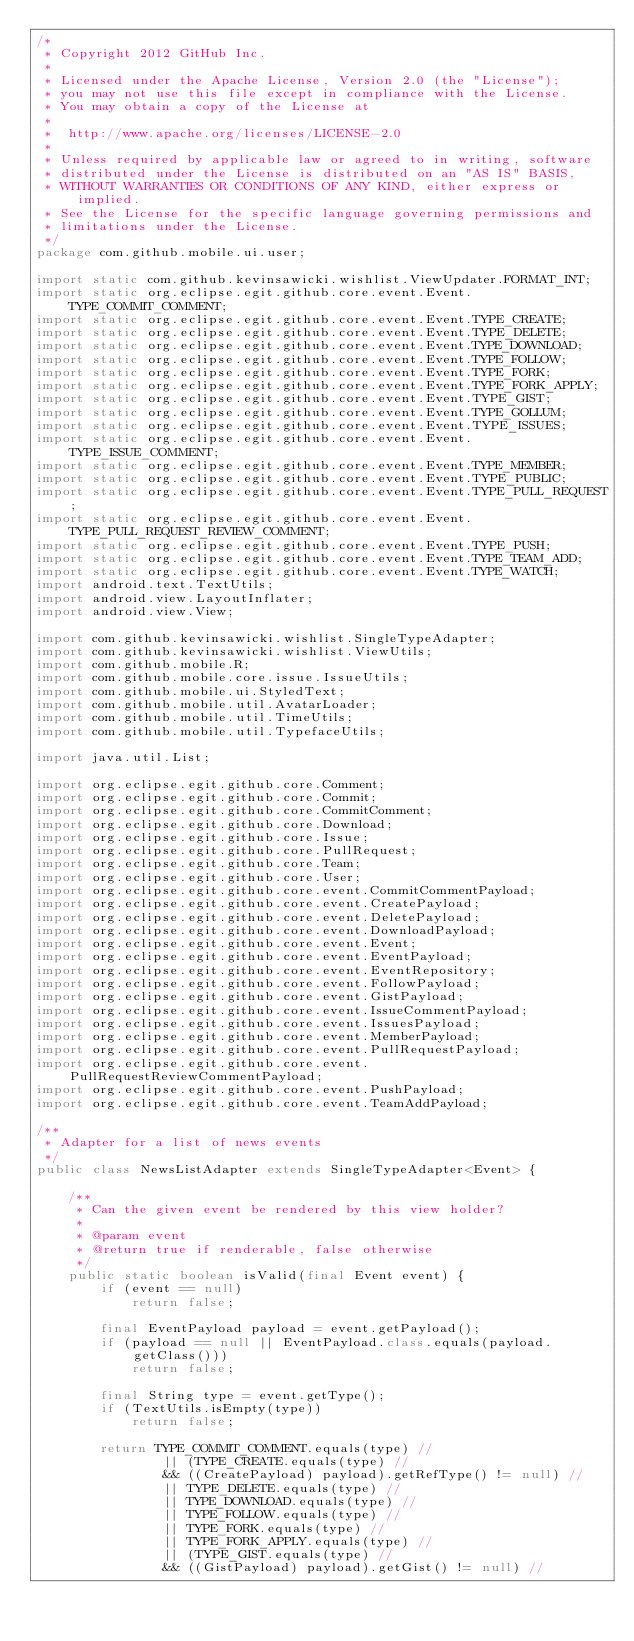Convert code to text. <code><loc_0><loc_0><loc_500><loc_500><_Java_>/*
 * Copyright 2012 GitHub Inc.
 *
 * Licensed under the Apache License, Version 2.0 (the "License");
 * you may not use this file except in compliance with the License.
 * You may obtain a copy of the License at
 *
 *  http://www.apache.org/licenses/LICENSE-2.0
 *
 * Unless required by applicable law or agreed to in writing, software
 * distributed under the License is distributed on an "AS IS" BASIS,
 * WITHOUT WARRANTIES OR CONDITIONS OF ANY KIND, either express or implied.
 * See the License for the specific language governing permissions and
 * limitations under the License.
 */
package com.github.mobile.ui.user;

import static com.github.kevinsawicki.wishlist.ViewUpdater.FORMAT_INT;
import static org.eclipse.egit.github.core.event.Event.TYPE_COMMIT_COMMENT;
import static org.eclipse.egit.github.core.event.Event.TYPE_CREATE;
import static org.eclipse.egit.github.core.event.Event.TYPE_DELETE;
import static org.eclipse.egit.github.core.event.Event.TYPE_DOWNLOAD;
import static org.eclipse.egit.github.core.event.Event.TYPE_FOLLOW;
import static org.eclipse.egit.github.core.event.Event.TYPE_FORK;
import static org.eclipse.egit.github.core.event.Event.TYPE_FORK_APPLY;
import static org.eclipse.egit.github.core.event.Event.TYPE_GIST;
import static org.eclipse.egit.github.core.event.Event.TYPE_GOLLUM;
import static org.eclipse.egit.github.core.event.Event.TYPE_ISSUES;
import static org.eclipse.egit.github.core.event.Event.TYPE_ISSUE_COMMENT;
import static org.eclipse.egit.github.core.event.Event.TYPE_MEMBER;
import static org.eclipse.egit.github.core.event.Event.TYPE_PUBLIC;
import static org.eclipse.egit.github.core.event.Event.TYPE_PULL_REQUEST;
import static org.eclipse.egit.github.core.event.Event.TYPE_PULL_REQUEST_REVIEW_COMMENT;
import static org.eclipse.egit.github.core.event.Event.TYPE_PUSH;
import static org.eclipse.egit.github.core.event.Event.TYPE_TEAM_ADD;
import static org.eclipse.egit.github.core.event.Event.TYPE_WATCH;
import android.text.TextUtils;
import android.view.LayoutInflater;
import android.view.View;

import com.github.kevinsawicki.wishlist.SingleTypeAdapter;
import com.github.kevinsawicki.wishlist.ViewUtils;
import com.github.mobile.R;
import com.github.mobile.core.issue.IssueUtils;
import com.github.mobile.ui.StyledText;
import com.github.mobile.util.AvatarLoader;
import com.github.mobile.util.TimeUtils;
import com.github.mobile.util.TypefaceUtils;

import java.util.List;

import org.eclipse.egit.github.core.Comment;
import org.eclipse.egit.github.core.Commit;
import org.eclipse.egit.github.core.CommitComment;
import org.eclipse.egit.github.core.Download;
import org.eclipse.egit.github.core.Issue;
import org.eclipse.egit.github.core.PullRequest;
import org.eclipse.egit.github.core.Team;
import org.eclipse.egit.github.core.User;
import org.eclipse.egit.github.core.event.CommitCommentPayload;
import org.eclipse.egit.github.core.event.CreatePayload;
import org.eclipse.egit.github.core.event.DeletePayload;
import org.eclipse.egit.github.core.event.DownloadPayload;
import org.eclipse.egit.github.core.event.Event;
import org.eclipse.egit.github.core.event.EventPayload;
import org.eclipse.egit.github.core.event.EventRepository;
import org.eclipse.egit.github.core.event.FollowPayload;
import org.eclipse.egit.github.core.event.GistPayload;
import org.eclipse.egit.github.core.event.IssueCommentPayload;
import org.eclipse.egit.github.core.event.IssuesPayload;
import org.eclipse.egit.github.core.event.MemberPayload;
import org.eclipse.egit.github.core.event.PullRequestPayload;
import org.eclipse.egit.github.core.event.PullRequestReviewCommentPayload;
import org.eclipse.egit.github.core.event.PushPayload;
import org.eclipse.egit.github.core.event.TeamAddPayload;

/**
 * Adapter for a list of news events
 */
public class NewsListAdapter extends SingleTypeAdapter<Event> {

    /**
     * Can the given event be rendered by this view holder?
     *
     * @param event
     * @return true if renderable, false otherwise
     */
    public static boolean isValid(final Event event) {
        if (event == null)
            return false;

        final EventPayload payload = event.getPayload();
        if (payload == null || EventPayload.class.equals(payload.getClass()))
            return false;

        final String type = event.getType();
        if (TextUtils.isEmpty(type))
            return false;

        return TYPE_COMMIT_COMMENT.equals(type) //
                || (TYPE_CREATE.equals(type) //
                && ((CreatePayload) payload).getRefType() != null) //
                || TYPE_DELETE.equals(type) //
                || TYPE_DOWNLOAD.equals(type) //
                || TYPE_FOLLOW.equals(type) //
                || TYPE_FORK.equals(type) //
                || TYPE_FORK_APPLY.equals(type) //
                || (TYPE_GIST.equals(type) //
                && ((GistPayload) payload).getGist() != null) //</code> 